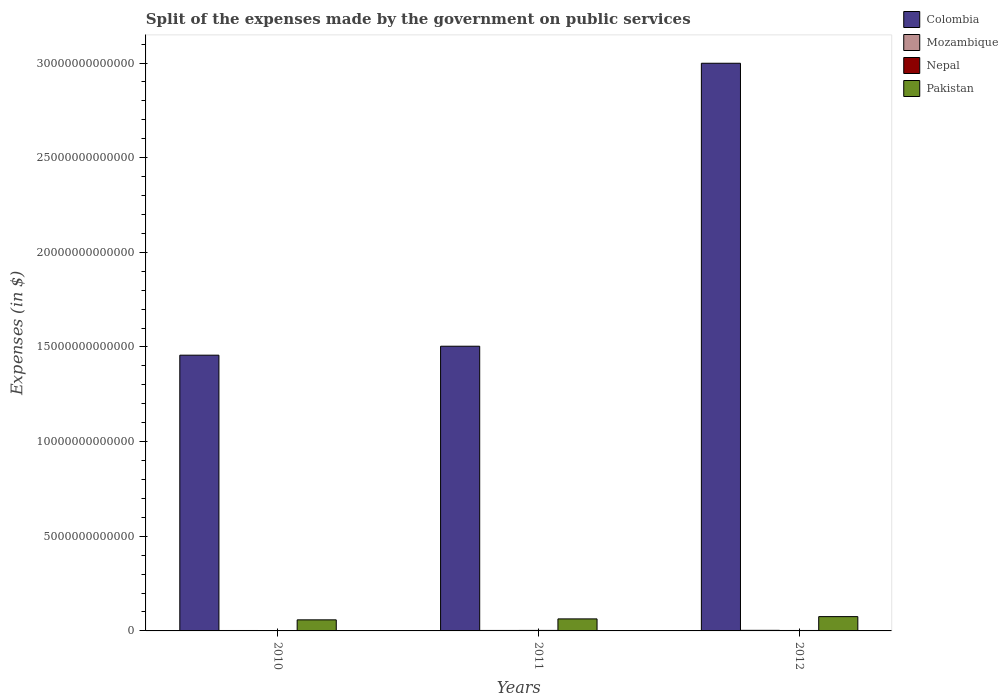How many different coloured bars are there?
Your answer should be compact. 4. How many groups of bars are there?
Make the answer very short. 3. How many bars are there on the 3rd tick from the left?
Make the answer very short. 4. What is the label of the 1st group of bars from the left?
Provide a short and direct response. 2010. In how many cases, is the number of bars for a given year not equal to the number of legend labels?
Provide a succinct answer. 0. What is the expenses made by the government on public services in Nepal in 2012?
Give a very brief answer. 2.38e+1. Across all years, what is the maximum expenses made by the government on public services in Mozambique?
Offer a very short reply. 3.05e+1. Across all years, what is the minimum expenses made by the government on public services in Pakistan?
Offer a very short reply. 5.85e+11. What is the total expenses made by the government on public services in Pakistan in the graph?
Give a very brief answer. 1.98e+12. What is the difference between the expenses made by the government on public services in Mozambique in 2011 and that in 2012?
Provide a succinct answer. -5.32e+09. What is the difference between the expenses made by the government on public services in Nepal in 2011 and the expenses made by the government on public services in Colombia in 2012?
Provide a succinct answer. -3.00e+13. What is the average expenses made by the government on public services in Colombia per year?
Your answer should be very brief. 1.99e+13. In the year 2010, what is the difference between the expenses made by the government on public services in Nepal and expenses made by the government on public services in Colombia?
Give a very brief answer. -1.45e+13. What is the ratio of the expenses made by the government on public services in Mozambique in 2010 to that in 2012?
Your answer should be very brief. 0.73. Is the expenses made by the government on public services in Pakistan in 2010 less than that in 2012?
Ensure brevity in your answer.  Yes. What is the difference between the highest and the second highest expenses made by the government on public services in Pakistan?
Ensure brevity in your answer.  1.20e+11. What is the difference between the highest and the lowest expenses made by the government on public services in Mozambique?
Offer a very short reply. 8.15e+09. In how many years, is the expenses made by the government on public services in Colombia greater than the average expenses made by the government on public services in Colombia taken over all years?
Give a very brief answer. 1. Is the sum of the expenses made by the government on public services in Colombia in 2011 and 2012 greater than the maximum expenses made by the government on public services in Nepal across all years?
Keep it short and to the point. Yes. Is it the case that in every year, the sum of the expenses made by the government on public services in Colombia and expenses made by the government on public services in Mozambique is greater than the sum of expenses made by the government on public services in Pakistan and expenses made by the government on public services in Nepal?
Your answer should be compact. No. What does the 4th bar from the left in 2010 represents?
Keep it short and to the point. Pakistan. What does the 2nd bar from the right in 2010 represents?
Keep it short and to the point. Nepal. How many bars are there?
Keep it short and to the point. 12. How many years are there in the graph?
Provide a short and direct response. 3. What is the difference between two consecutive major ticks on the Y-axis?
Ensure brevity in your answer.  5.00e+12. Does the graph contain grids?
Offer a terse response. No. Where does the legend appear in the graph?
Make the answer very short. Top right. How many legend labels are there?
Give a very brief answer. 4. How are the legend labels stacked?
Your answer should be compact. Vertical. What is the title of the graph?
Provide a short and direct response. Split of the expenses made by the government on public services. Does "Russian Federation" appear as one of the legend labels in the graph?
Give a very brief answer. No. What is the label or title of the X-axis?
Give a very brief answer. Years. What is the label or title of the Y-axis?
Your answer should be very brief. Expenses (in $). What is the Expenses (in $) of Colombia in 2010?
Make the answer very short. 1.46e+13. What is the Expenses (in $) in Mozambique in 2010?
Your answer should be very brief. 2.24e+1. What is the Expenses (in $) of Nepal in 2010?
Make the answer very short. 1.94e+1. What is the Expenses (in $) in Pakistan in 2010?
Provide a short and direct response. 5.85e+11. What is the Expenses (in $) of Colombia in 2011?
Provide a short and direct response. 1.50e+13. What is the Expenses (in $) of Mozambique in 2011?
Ensure brevity in your answer.  2.52e+1. What is the Expenses (in $) in Nepal in 2011?
Offer a very short reply. 2.71e+1. What is the Expenses (in $) of Pakistan in 2011?
Your response must be concise. 6.35e+11. What is the Expenses (in $) of Colombia in 2012?
Provide a short and direct response. 3.00e+13. What is the Expenses (in $) of Mozambique in 2012?
Give a very brief answer. 3.05e+1. What is the Expenses (in $) of Nepal in 2012?
Offer a very short reply. 2.38e+1. What is the Expenses (in $) of Pakistan in 2012?
Your answer should be compact. 7.55e+11. Across all years, what is the maximum Expenses (in $) of Colombia?
Your response must be concise. 3.00e+13. Across all years, what is the maximum Expenses (in $) in Mozambique?
Your answer should be compact. 3.05e+1. Across all years, what is the maximum Expenses (in $) in Nepal?
Your answer should be very brief. 2.71e+1. Across all years, what is the maximum Expenses (in $) in Pakistan?
Offer a very short reply. 7.55e+11. Across all years, what is the minimum Expenses (in $) in Colombia?
Your answer should be compact. 1.46e+13. Across all years, what is the minimum Expenses (in $) of Mozambique?
Give a very brief answer. 2.24e+1. Across all years, what is the minimum Expenses (in $) in Nepal?
Your answer should be very brief. 1.94e+1. Across all years, what is the minimum Expenses (in $) of Pakistan?
Ensure brevity in your answer.  5.85e+11. What is the total Expenses (in $) of Colombia in the graph?
Provide a succinct answer. 5.96e+13. What is the total Expenses (in $) of Mozambique in the graph?
Your answer should be very brief. 7.81e+1. What is the total Expenses (in $) of Nepal in the graph?
Your answer should be very brief. 7.03e+1. What is the total Expenses (in $) in Pakistan in the graph?
Keep it short and to the point. 1.98e+12. What is the difference between the Expenses (in $) in Colombia in 2010 and that in 2011?
Offer a very short reply. -4.73e+11. What is the difference between the Expenses (in $) in Mozambique in 2010 and that in 2011?
Provide a short and direct response. -2.84e+09. What is the difference between the Expenses (in $) of Nepal in 2010 and that in 2011?
Your answer should be very brief. -7.75e+09. What is the difference between the Expenses (in $) of Pakistan in 2010 and that in 2011?
Your answer should be compact. -5.01e+1. What is the difference between the Expenses (in $) of Colombia in 2010 and that in 2012?
Make the answer very short. -1.54e+13. What is the difference between the Expenses (in $) in Mozambique in 2010 and that in 2012?
Provide a succinct answer. -8.15e+09. What is the difference between the Expenses (in $) of Nepal in 2010 and that in 2012?
Your answer should be very brief. -4.37e+09. What is the difference between the Expenses (in $) of Pakistan in 2010 and that in 2012?
Your answer should be very brief. -1.70e+11. What is the difference between the Expenses (in $) in Colombia in 2011 and that in 2012?
Provide a short and direct response. -1.49e+13. What is the difference between the Expenses (in $) of Mozambique in 2011 and that in 2012?
Offer a very short reply. -5.32e+09. What is the difference between the Expenses (in $) in Nepal in 2011 and that in 2012?
Provide a short and direct response. 3.38e+09. What is the difference between the Expenses (in $) in Pakistan in 2011 and that in 2012?
Your answer should be very brief. -1.20e+11. What is the difference between the Expenses (in $) of Colombia in 2010 and the Expenses (in $) of Mozambique in 2011?
Ensure brevity in your answer.  1.45e+13. What is the difference between the Expenses (in $) of Colombia in 2010 and the Expenses (in $) of Nepal in 2011?
Your response must be concise. 1.45e+13. What is the difference between the Expenses (in $) of Colombia in 2010 and the Expenses (in $) of Pakistan in 2011?
Offer a terse response. 1.39e+13. What is the difference between the Expenses (in $) in Mozambique in 2010 and the Expenses (in $) in Nepal in 2011?
Make the answer very short. -4.77e+09. What is the difference between the Expenses (in $) in Mozambique in 2010 and the Expenses (in $) in Pakistan in 2011?
Keep it short and to the point. -6.13e+11. What is the difference between the Expenses (in $) in Nepal in 2010 and the Expenses (in $) in Pakistan in 2011?
Your answer should be very brief. -6.16e+11. What is the difference between the Expenses (in $) in Colombia in 2010 and the Expenses (in $) in Mozambique in 2012?
Provide a succinct answer. 1.45e+13. What is the difference between the Expenses (in $) of Colombia in 2010 and the Expenses (in $) of Nepal in 2012?
Your response must be concise. 1.45e+13. What is the difference between the Expenses (in $) of Colombia in 2010 and the Expenses (in $) of Pakistan in 2012?
Provide a short and direct response. 1.38e+13. What is the difference between the Expenses (in $) of Mozambique in 2010 and the Expenses (in $) of Nepal in 2012?
Ensure brevity in your answer.  -1.38e+09. What is the difference between the Expenses (in $) in Mozambique in 2010 and the Expenses (in $) in Pakistan in 2012?
Your answer should be very brief. -7.33e+11. What is the difference between the Expenses (in $) in Nepal in 2010 and the Expenses (in $) in Pakistan in 2012?
Offer a very short reply. -7.36e+11. What is the difference between the Expenses (in $) in Colombia in 2011 and the Expenses (in $) in Mozambique in 2012?
Make the answer very short. 1.50e+13. What is the difference between the Expenses (in $) in Colombia in 2011 and the Expenses (in $) in Nepal in 2012?
Provide a short and direct response. 1.50e+13. What is the difference between the Expenses (in $) of Colombia in 2011 and the Expenses (in $) of Pakistan in 2012?
Ensure brevity in your answer.  1.43e+13. What is the difference between the Expenses (in $) of Mozambique in 2011 and the Expenses (in $) of Nepal in 2012?
Give a very brief answer. 1.45e+09. What is the difference between the Expenses (in $) of Mozambique in 2011 and the Expenses (in $) of Pakistan in 2012?
Your answer should be very brief. -7.30e+11. What is the difference between the Expenses (in $) of Nepal in 2011 and the Expenses (in $) of Pakistan in 2012?
Your answer should be very brief. -7.28e+11. What is the average Expenses (in $) in Colombia per year?
Offer a terse response. 1.99e+13. What is the average Expenses (in $) of Mozambique per year?
Offer a terse response. 2.60e+1. What is the average Expenses (in $) of Nepal per year?
Ensure brevity in your answer.  2.34e+1. What is the average Expenses (in $) of Pakistan per year?
Offer a very short reply. 6.58e+11. In the year 2010, what is the difference between the Expenses (in $) of Colombia and Expenses (in $) of Mozambique?
Your answer should be compact. 1.45e+13. In the year 2010, what is the difference between the Expenses (in $) of Colombia and Expenses (in $) of Nepal?
Make the answer very short. 1.45e+13. In the year 2010, what is the difference between the Expenses (in $) of Colombia and Expenses (in $) of Pakistan?
Ensure brevity in your answer.  1.40e+13. In the year 2010, what is the difference between the Expenses (in $) of Mozambique and Expenses (in $) of Nepal?
Your answer should be compact. 2.99e+09. In the year 2010, what is the difference between the Expenses (in $) of Mozambique and Expenses (in $) of Pakistan?
Offer a very short reply. -5.62e+11. In the year 2010, what is the difference between the Expenses (in $) of Nepal and Expenses (in $) of Pakistan?
Make the answer very short. -5.65e+11. In the year 2011, what is the difference between the Expenses (in $) of Colombia and Expenses (in $) of Mozambique?
Keep it short and to the point. 1.50e+13. In the year 2011, what is the difference between the Expenses (in $) of Colombia and Expenses (in $) of Nepal?
Keep it short and to the point. 1.50e+13. In the year 2011, what is the difference between the Expenses (in $) of Colombia and Expenses (in $) of Pakistan?
Your response must be concise. 1.44e+13. In the year 2011, what is the difference between the Expenses (in $) in Mozambique and Expenses (in $) in Nepal?
Provide a succinct answer. -1.93e+09. In the year 2011, what is the difference between the Expenses (in $) of Mozambique and Expenses (in $) of Pakistan?
Give a very brief answer. -6.10e+11. In the year 2011, what is the difference between the Expenses (in $) in Nepal and Expenses (in $) in Pakistan?
Give a very brief answer. -6.08e+11. In the year 2012, what is the difference between the Expenses (in $) in Colombia and Expenses (in $) in Mozambique?
Offer a terse response. 3.00e+13. In the year 2012, what is the difference between the Expenses (in $) in Colombia and Expenses (in $) in Nepal?
Keep it short and to the point. 3.00e+13. In the year 2012, what is the difference between the Expenses (in $) of Colombia and Expenses (in $) of Pakistan?
Keep it short and to the point. 2.92e+13. In the year 2012, what is the difference between the Expenses (in $) in Mozambique and Expenses (in $) in Nepal?
Make the answer very short. 6.77e+09. In the year 2012, what is the difference between the Expenses (in $) of Mozambique and Expenses (in $) of Pakistan?
Ensure brevity in your answer.  -7.25e+11. In the year 2012, what is the difference between the Expenses (in $) of Nepal and Expenses (in $) of Pakistan?
Give a very brief answer. -7.32e+11. What is the ratio of the Expenses (in $) of Colombia in 2010 to that in 2011?
Give a very brief answer. 0.97. What is the ratio of the Expenses (in $) in Mozambique in 2010 to that in 2011?
Offer a terse response. 0.89. What is the ratio of the Expenses (in $) of Nepal in 2010 to that in 2011?
Provide a short and direct response. 0.71. What is the ratio of the Expenses (in $) in Pakistan in 2010 to that in 2011?
Keep it short and to the point. 0.92. What is the ratio of the Expenses (in $) in Colombia in 2010 to that in 2012?
Provide a short and direct response. 0.49. What is the ratio of the Expenses (in $) in Mozambique in 2010 to that in 2012?
Keep it short and to the point. 0.73. What is the ratio of the Expenses (in $) of Nepal in 2010 to that in 2012?
Provide a succinct answer. 0.82. What is the ratio of the Expenses (in $) of Pakistan in 2010 to that in 2012?
Provide a short and direct response. 0.77. What is the ratio of the Expenses (in $) in Colombia in 2011 to that in 2012?
Give a very brief answer. 0.5. What is the ratio of the Expenses (in $) of Mozambique in 2011 to that in 2012?
Provide a short and direct response. 0.83. What is the ratio of the Expenses (in $) of Nepal in 2011 to that in 2012?
Provide a short and direct response. 1.14. What is the ratio of the Expenses (in $) in Pakistan in 2011 to that in 2012?
Your answer should be very brief. 0.84. What is the difference between the highest and the second highest Expenses (in $) of Colombia?
Provide a short and direct response. 1.49e+13. What is the difference between the highest and the second highest Expenses (in $) in Mozambique?
Keep it short and to the point. 5.32e+09. What is the difference between the highest and the second highest Expenses (in $) in Nepal?
Your answer should be very brief. 3.38e+09. What is the difference between the highest and the second highest Expenses (in $) of Pakistan?
Give a very brief answer. 1.20e+11. What is the difference between the highest and the lowest Expenses (in $) of Colombia?
Provide a short and direct response. 1.54e+13. What is the difference between the highest and the lowest Expenses (in $) of Mozambique?
Offer a terse response. 8.15e+09. What is the difference between the highest and the lowest Expenses (in $) of Nepal?
Keep it short and to the point. 7.75e+09. What is the difference between the highest and the lowest Expenses (in $) in Pakistan?
Offer a terse response. 1.70e+11. 